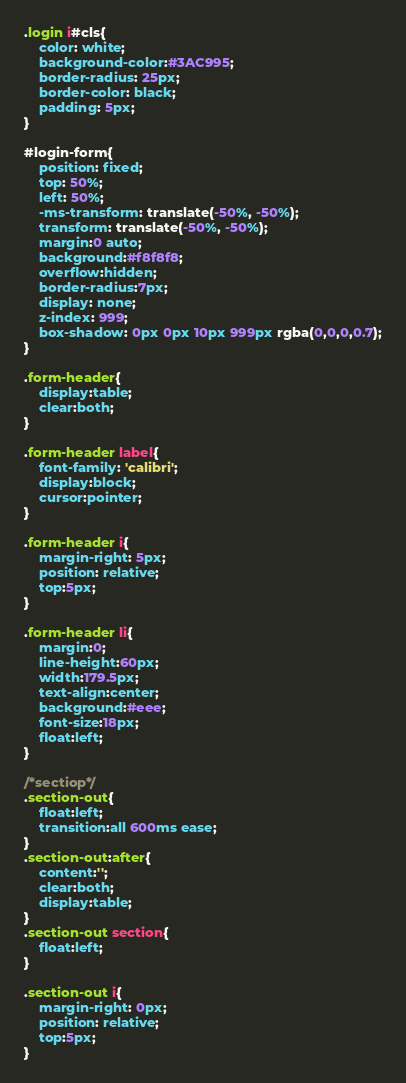<code> <loc_0><loc_0><loc_500><loc_500><_CSS_>.login i#cls{
	color: white;
	background-color:#3AC995;
	border-radius: 25px;
	border-color: black;
	padding: 5px;
}

#login-form{
	position: fixed;
	top: 50%;
    left: 50%;
    -ms-transform: translate(-50%, -50%);
    transform: translate(-50%, -50%);
	margin:0 auto; 
	background:#f8f8f8; 
	overflow:hidden; 
	border-radius:7px;
	display: none;
	z-index: 999;
	box-shadow: 0px 0px 10px 999px rgba(0,0,0,0.7);
}

.form-header{
	display:table; 
	clear:both;
}

.form-header label{
	font-family: 'calibri';
	display:block; 
	cursor:pointer; 
}

.form-header i{
	margin-right: 5px;
	position: relative;
	top:5px;
}

.form-header li{
	margin:0; 
	line-height:60px; 
	width:179.5px; 
	text-align:center; 
	background:#eee; 
	font-size:18px; 
	float:left; 
}

/*sectiop*/
.section-out{
	float:left; 
	transition:all 600ms ease;
}
.section-out:after{
	content:''; 
	clear:both; 
	display:table;
}
.section-out section{ 
	float:left;
}

.section-out i{
	margin-right: 0px;
	position: relative;
	top:5px;
}
</code> 